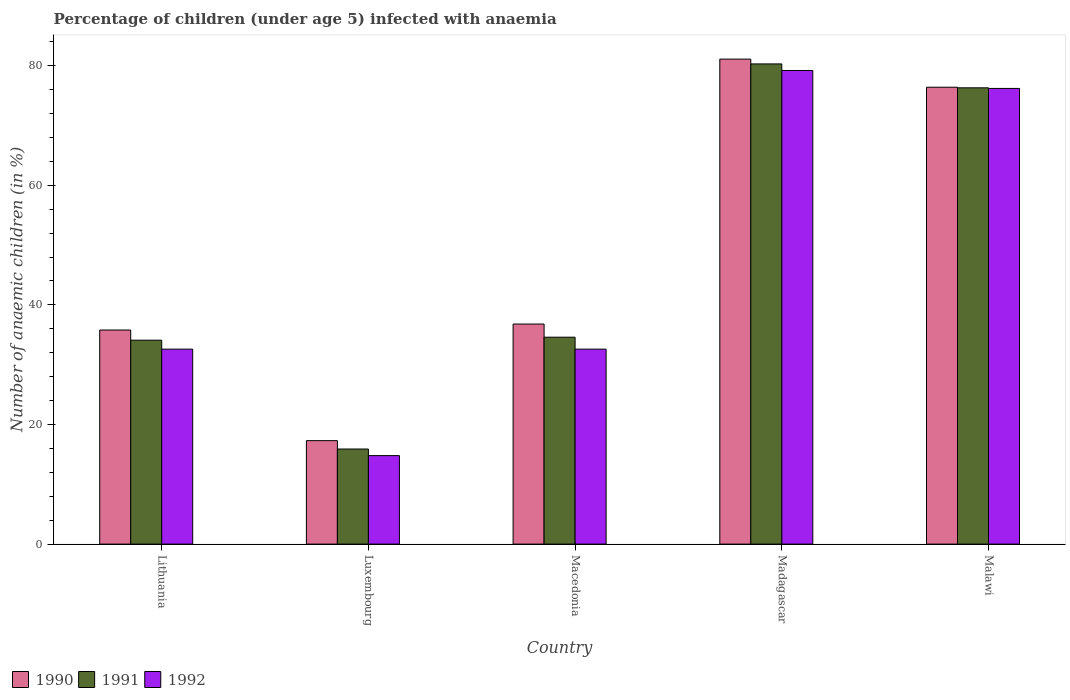How many bars are there on the 3rd tick from the left?
Keep it short and to the point. 3. How many bars are there on the 2nd tick from the right?
Keep it short and to the point. 3. What is the label of the 5th group of bars from the left?
Offer a terse response. Malawi. What is the percentage of children infected with anaemia in in 1992 in Madagascar?
Give a very brief answer. 79.2. Across all countries, what is the maximum percentage of children infected with anaemia in in 1991?
Make the answer very short. 80.3. Across all countries, what is the minimum percentage of children infected with anaemia in in 1992?
Your answer should be compact. 14.8. In which country was the percentage of children infected with anaemia in in 1991 maximum?
Keep it short and to the point. Madagascar. In which country was the percentage of children infected with anaemia in in 1992 minimum?
Keep it short and to the point. Luxembourg. What is the total percentage of children infected with anaemia in in 1992 in the graph?
Keep it short and to the point. 235.4. What is the difference between the percentage of children infected with anaemia in in 1991 in Luxembourg and that in Madagascar?
Offer a very short reply. -64.4. What is the average percentage of children infected with anaemia in in 1990 per country?
Give a very brief answer. 49.48. What is the difference between the percentage of children infected with anaemia in of/in 1990 and percentage of children infected with anaemia in of/in 1991 in Lithuania?
Your answer should be very brief. 1.7. What is the ratio of the percentage of children infected with anaemia in in 1991 in Luxembourg to that in Malawi?
Make the answer very short. 0.21. Is the difference between the percentage of children infected with anaemia in in 1990 in Lithuania and Macedonia greater than the difference between the percentage of children infected with anaemia in in 1991 in Lithuania and Macedonia?
Ensure brevity in your answer.  No. What is the difference between the highest and the second highest percentage of children infected with anaemia in in 1991?
Provide a short and direct response. 45.7. What is the difference between the highest and the lowest percentage of children infected with anaemia in in 1992?
Keep it short and to the point. 64.4. In how many countries, is the percentage of children infected with anaemia in in 1991 greater than the average percentage of children infected with anaemia in in 1991 taken over all countries?
Keep it short and to the point. 2. Is the sum of the percentage of children infected with anaemia in in 1992 in Lithuania and Madagascar greater than the maximum percentage of children infected with anaemia in in 1990 across all countries?
Your response must be concise. Yes. What does the 3rd bar from the left in Lithuania represents?
Your answer should be compact. 1992. What does the 3rd bar from the right in Malawi represents?
Provide a succinct answer. 1990. Is it the case that in every country, the sum of the percentage of children infected with anaemia in in 1992 and percentage of children infected with anaemia in in 1990 is greater than the percentage of children infected with anaemia in in 1991?
Offer a terse response. Yes. How many countries are there in the graph?
Your answer should be compact. 5. What is the difference between two consecutive major ticks on the Y-axis?
Keep it short and to the point. 20. Where does the legend appear in the graph?
Provide a short and direct response. Bottom left. How are the legend labels stacked?
Your response must be concise. Horizontal. What is the title of the graph?
Your answer should be compact. Percentage of children (under age 5) infected with anaemia. What is the label or title of the Y-axis?
Ensure brevity in your answer.  Number of anaemic children (in %). What is the Number of anaemic children (in %) in 1990 in Lithuania?
Make the answer very short. 35.8. What is the Number of anaemic children (in %) of 1991 in Lithuania?
Offer a very short reply. 34.1. What is the Number of anaemic children (in %) of 1992 in Lithuania?
Offer a very short reply. 32.6. What is the Number of anaemic children (in %) of 1990 in Luxembourg?
Provide a short and direct response. 17.3. What is the Number of anaemic children (in %) of 1991 in Luxembourg?
Keep it short and to the point. 15.9. What is the Number of anaemic children (in %) of 1990 in Macedonia?
Ensure brevity in your answer.  36.8. What is the Number of anaemic children (in %) of 1991 in Macedonia?
Provide a short and direct response. 34.6. What is the Number of anaemic children (in %) in 1992 in Macedonia?
Give a very brief answer. 32.6. What is the Number of anaemic children (in %) of 1990 in Madagascar?
Make the answer very short. 81.1. What is the Number of anaemic children (in %) of 1991 in Madagascar?
Make the answer very short. 80.3. What is the Number of anaemic children (in %) in 1992 in Madagascar?
Keep it short and to the point. 79.2. What is the Number of anaemic children (in %) in 1990 in Malawi?
Offer a terse response. 76.4. What is the Number of anaemic children (in %) in 1991 in Malawi?
Give a very brief answer. 76.3. What is the Number of anaemic children (in %) in 1992 in Malawi?
Offer a very short reply. 76.2. Across all countries, what is the maximum Number of anaemic children (in %) in 1990?
Your answer should be compact. 81.1. Across all countries, what is the maximum Number of anaemic children (in %) of 1991?
Your response must be concise. 80.3. Across all countries, what is the maximum Number of anaemic children (in %) in 1992?
Ensure brevity in your answer.  79.2. Across all countries, what is the minimum Number of anaemic children (in %) of 1990?
Give a very brief answer. 17.3. Across all countries, what is the minimum Number of anaemic children (in %) of 1991?
Provide a short and direct response. 15.9. Across all countries, what is the minimum Number of anaemic children (in %) in 1992?
Provide a short and direct response. 14.8. What is the total Number of anaemic children (in %) in 1990 in the graph?
Ensure brevity in your answer.  247.4. What is the total Number of anaemic children (in %) of 1991 in the graph?
Give a very brief answer. 241.2. What is the total Number of anaemic children (in %) in 1992 in the graph?
Offer a terse response. 235.4. What is the difference between the Number of anaemic children (in %) in 1992 in Lithuania and that in Luxembourg?
Ensure brevity in your answer.  17.8. What is the difference between the Number of anaemic children (in %) in 1990 in Lithuania and that in Macedonia?
Offer a terse response. -1. What is the difference between the Number of anaemic children (in %) of 1991 in Lithuania and that in Macedonia?
Make the answer very short. -0.5. What is the difference between the Number of anaemic children (in %) of 1992 in Lithuania and that in Macedonia?
Provide a succinct answer. 0. What is the difference between the Number of anaemic children (in %) of 1990 in Lithuania and that in Madagascar?
Your answer should be compact. -45.3. What is the difference between the Number of anaemic children (in %) in 1991 in Lithuania and that in Madagascar?
Provide a succinct answer. -46.2. What is the difference between the Number of anaemic children (in %) of 1992 in Lithuania and that in Madagascar?
Offer a very short reply. -46.6. What is the difference between the Number of anaemic children (in %) of 1990 in Lithuania and that in Malawi?
Your answer should be compact. -40.6. What is the difference between the Number of anaemic children (in %) of 1991 in Lithuania and that in Malawi?
Your response must be concise. -42.2. What is the difference between the Number of anaemic children (in %) in 1992 in Lithuania and that in Malawi?
Your response must be concise. -43.6. What is the difference between the Number of anaemic children (in %) of 1990 in Luxembourg and that in Macedonia?
Ensure brevity in your answer.  -19.5. What is the difference between the Number of anaemic children (in %) of 1991 in Luxembourg and that in Macedonia?
Provide a succinct answer. -18.7. What is the difference between the Number of anaemic children (in %) of 1992 in Luxembourg and that in Macedonia?
Your answer should be compact. -17.8. What is the difference between the Number of anaemic children (in %) in 1990 in Luxembourg and that in Madagascar?
Your answer should be very brief. -63.8. What is the difference between the Number of anaemic children (in %) in 1991 in Luxembourg and that in Madagascar?
Give a very brief answer. -64.4. What is the difference between the Number of anaemic children (in %) of 1992 in Luxembourg and that in Madagascar?
Ensure brevity in your answer.  -64.4. What is the difference between the Number of anaemic children (in %) in 1990 in Luxembourg and that in Malawi?
Your answer should be very brief. -59.1. What is the difference between the Number of anaemic children (in %) in 1991 in Luxembourg and that in Malawi?
Provide a succinct answer. -60.4. What is the difference between the Number of anaemic children (in %) of 1992 in Luxembourg and that in Malawi?
Your answer should be compact. -61.4. What is the difference between the Number of anaemic children (in %) in 1990 in Macedonia and that in Madagascar?
Keep it short and to the point. -44.3. What is the difference between the Number of anaemic children (in %) in 1991 in Macedonia and that in Madagascar?
Offer a very short reply. -45.7. What is the difference between the Number of anaemic children (in %) in 1992 in Macedonia and that in Madagascar?
Your response must be concise. -46.6. What is the difference between the Number of anaemic children (in %) of 1990 in Macedonia and that in Malawi?
Ensure brevity in your answer.  -39.6. What is the difference between the Number of anaemic children (in %) of 1991 in Macedonia and that in Malawi?
Your response must be concise. -41.7. What is the difference between the Number of anaemic children (in %) of 1992 in Macedonia and that in Malawi?
Ensure brevity in your answer.  -43.6. What is the difference between the Number of anaemic children (in %) of 1992 in Madagascar and that in Malawi?
Your answer should be very brief. 3. What is the difference between the Number of anaemic children (in %) of 1991 in Lithuania and the Number of anaemic children (in %) of 1992 in Luxembourg?
Keep it short and to the point. 19.3. What is the difference between the Number of anaemic children (in %) of 1990 in Lithuania and the Number of anaemic children (in %) of 1991 in Macedonia?
Offer a terse response. 1.2. What is the difference between the Number of anaemic children (in %) of 1991 in Lithuania and the Number of anaemic children (in %) of 1992 in Macedonia?
Ensure brevity in your answer.  1.5. What is the difference between the Number of anaemic children (in %) of 1990 in Lithuania and the Number of anaemic children (in %) of 1991 in Madagascar?
Offer a very short reply. -44.5. What is the difference between the Number of anaemic children (in %) in 1990 in Lithuania and the Number of anaemic children (in %) in 1992 in Madagascar?
Your answer should be compact. -43.4. What is the difference between the Number of anaemic children (in %) of 1991 in Lithuania and the Number of anaemic children (in %) of 1992 in Madagascar?
Your answer should be compact. -45.1. What is the difference between the Number of anaemic children (in %) in 1990 in Lithuania and the Number of anaemic children (in %) in 1991 in Malawi?
Give a very brief answer. -40.5. What is the difference between the Number of anaemic children (in %) in 1990 in Lithuania and the Number of anaemic children (in %) in 1992 in Malawi?
Provide a succinct answer. -40.4. What is the difference between the Number of anaemic children (in %) of 1991 in Lithuania and the Number of anaemic children (in %) of 1992 in Malawi?
Offer a terse response. -42.1. What is the difference between the Number of anaemic children (in %) in 1990 in Luxembourg and the Number of anaemic children (in %) in 1991 in Macedonia?
Provide a succinct answer. -17.3. What is the difference between the Number of anaemic children (in %) in 1990 in Luxembourg and the Number of anaemic children (in %) in 1992 in Macedonia?
Offer a very short reply. -15.3. What is the difference between the Number of anaemic children (in %) of 1991 in Luxembourg and the Number of anaemic children (in %) of 1992 in Macedonia?
Make the answer very short. -16.7. What is the difference between the Number of anaemic children (in %) in 1990 in Luxembourg and the Number of anaemic children (in %) in 1991 in Madagascar?
Your answer should be very brief. -63. What is the difference between the Number of anaemic children (in %) in 1990 in Luxembourg and the Number of anaemic children (in %) in 1992 in Madagascar?
Offer a very short reply. -61.9. What is the difference between the Number of anaemic children (in %) of 1991 in Luxembourg and the Number of anaemic children (in %) of 1992 in Madagascar?
Ensure brevity in your answer.  -63.3. What is the difference between the Number of anaemic children (in %) in 1990 in Luxembourg and the Number of anaemic children (in %) in 1991 in Malawi?
Offer a terse response. -59. What is the difference between the Number of anaemic children (in %) of 1990 in Luxembourg and the Number of anaemic children (in %) of 1992 in Malawi?
Keep it short and to the point. -58.9. What is the difference between the Number of anaemic children (in %) in 1991 in Luxembourg and the Number of anaemic children (in %) in 1992 in Malawi?
Keep it short and to the point. -60.3. What is the difference between the Number of anaemic children (in %) in 1990 in Macedonia and the Number of anaemic children (in %) in 1991 in Madagascar?
Ensure brevity in your answer.  -43.5. What is the difference between the Number of anaemic children (in %) in 1990 in Macedonia and the Number of anaemic children (in %) in 1992 in Madagascar?
Ensure brevity in your answer.  -42.4. What is the difference between the Number of anaemic children (in %) of 1991 in Macedonia and the Number of anaemic children (in %) of 1992 in Madagascar?
Your answer should be very brief. -44.6. What is the difference between the Number of anaemic children (in %) of 1990 in Macedonia and the Number of anaemic children (in %) of 1991 in Malawi?
Make the answer very short. -39.5. What is the difference between the Number of anaemic children (in %) in 1990 in Macedonia and the Number of anaemic children (in %) in 1992 in Malawi?
Provide a succinct answer. -39.4. What is the difference between the Number of anaemic children (in %) in 1991 in Macedonia and the Number of anaemic children (in %) in 1992 in Malawi?
Make the answer very short. -41.6. What is the difference between the Number of anaemic children (in %) in 1990 in Madagascar and the Number of anaemic children (in %) in 1992 in Malawi?
Offer a terse response. 4.9. What is the average Number of anaemic children (in %) in 1990 per country?
Give a very brief answer. 49.48. What is the average Number of anaemic children (in %) in 1991 per country?
Ensure brevity in your answer.  48.24. What is the average Number of anaemic children (in %) in 1992 per country?
Offer a terse response. 47.08. What is the difference between the Number of anaemic children (in %) in 1990 and Number of anaemic children (in %) in 1992 in Luxembourg?
Your answer should be very brief. 2.5. What is the difference between the Number of anaemic children (in %) in 1991 and Number of anaemic children (in %) in 1992 in Macedonia?
Give a very brief answer. 2. What is the difference between the Number of anaemic children (in %) of 1990 and Number of anaemic children (in %) of 1992 in Madagascar?
Offer a terse response. 1.9. What is the difference between the Number of anaemic children (in %) of 1991 and Number of anaemic children (in %) of 1992 in Madagascar?
Your answer should be very brief. 1.1. What is the difference between the Number of anaemic children (in %) in 1990 and Number of anaemic children (in %) in 1991 in Malawi?
Provide a short and direct response. 0.1. What is the difference between the Number of anaemic children (in %) of 1990 and Number of anaemic children (in %) of 1992 in Malawi?
Provide a succinct answer. 0.2. What is the ratio of the Number of anaemic children (in %) of 1990 in Lithuania to that in Luxembourg?
Offer a very short reply. 2.07. What is the ratio of the Number of anaemic children (in %) of 1991 in Lithuania to that in Luxembourg?
Ensure brevity in your answer.  2.14. What is the ratio of the Number of anaemic children (in %) in 1992 in Lithuania to that in Luxembourg?
Offer a very short reply. 2.2. What is the ratio of the Number of anaemic children (in %) in 1990 in Lithuania to that in Macedonia?
Keep it short and to the point. 0.97. What is the ratio of the Number of anaemic children (in %) of 1991 in Lithuania to that in Macedonia?
Provide a succinct answer. 0.99. What is the ratio of the Number of anaemic children (in %) in 1992 in Lithuania to that in Macedonia?
Your answer should be compact. 1. What is the ratio of the Number of anaemic children (in %) of 1990 in Lithuania to that in Madagascar?
Offer a very short reply. 0.44. What is the ratio of the Number of anaemic children (in %) in 1991 in Lithuania to that in Madagascar?
Give a very brief answer. 0.42. What is the ratio of the Number of anaemic children (in %) of 1992 in Lithuania to that in Madagascar?
Make the answer very short. 0.41. What is the ratio of the Number of anaemic children (in %) in 1990 in Lithuania to that in Malawi?
Offer a terse response. 0.47. What is the ratio of the Number of anaemic children (in %) of 1991 in Lithuania to that in Malawi?
Provide a short and direct response. 0.45. What is the ratio of the Number of anaemic children (in %) in 1992 in Lithuania to that in Malawi?
Your answer should be very brief. 0.43. What is the ratio of the Number of anaemic children (in %) in 1990 in Luxembourg to that in Macedonia?
Provide a short and direct response. 0.47. What is the ratio of the Number of anaemic children (in %) in 1991 in Luxembourg to that in Macedonia?
Your answer should be very brief. 0.46. What is the ratio of the Number of anaemic children (in %) of 1992 in Luxembourg to that in Macedonia?
Your answer should be compact. 0.45. What is the ratio of the Number of anaemic children (in %) in 1990 in Luxembourg to that in Madagascar?
Your response must be concise. 0.21. What is the ratio of the Number of anaemic children (in %) of 1991 in Luxembourg to that in Madagascar?
Make the answer very short. 0.2. What is the ratio of the Number of anaemic children (in %) in 1992 in Luxembourg to that in Madagascar?
Offer a very short reply. 0.19. What is the ratio of the Number of anaemic children (in %) in 1990 in Luxembourg to that in Malawi?
Make the answer very short. 0.23. What is the ratio of the Number of anaemic children (in %) in 1991 in Luxembourg to that in Malawi?
Provide a short and direct response. 0.21. What is the ratio of the Number of anaemic children (in %) of 1992 in Luxembourg to that in Malawi?
Keep it short and to the point. 0.19. What is the ratio of the Number of anaemic children (in %) in 1990 in Macedonia to that in Madagascar?
Keep it short and to the point. 0.45. What is the ratio of the Number of anaemic children (in %) in 1991 in Macedonia to that in Madagascar?
Ensure brevity in your answer.  0.43. What is the ratio of the Number of anaemic children (in %) in 1992 in Macedonia to that in Madagascar?
Your response must be concise. 0.41. What is the ratio of the Number of anaemic children (in %) in 1990 in Macedonia to that in Malawi?
Your response must be concise. 0.48. What is the ratio of the Number of anaemic children (in %) in 1991 in Macedonia to that in Malawi?
Make the answer very short. 0.45. What is the ratio of the Number of anaemic children (in %) of 1992 in Macedonia to that in Malawi?
Provide a short and direct response. 0.43. What is the ratio of the Number of anaemic children (in %) of 1990 in Madagascar to that in Malawi?
Your answer should be compact. 1.06. What is the ratio of the Number of anaemic children (in %) in 1991 in Madagascar to that in Malawi?
Offer a very short reply. 1.05. What is the ratio of the Number of anaemic children (in %) of 1992 in Madagascar to that in Malawi?
Provide a succinct answer. 1.04. What is the difference between the highest and the second highest Number of anaemic children (in %) in 1992?
Keep it short and to the point. 3. What is the difference between the highest and the lowest Number of anaemic children (in %) of 1990?
Your answer should be compact. 63.8. What is the difference between the highest and the lowest Number of anaemic children (in %) in 1991?
Ensure brevity in your answer.  64.4. What is the difference between the highest and the lowest Number of anaemic children (in %) of 1992?
Your answer should be compact. 64.4. 